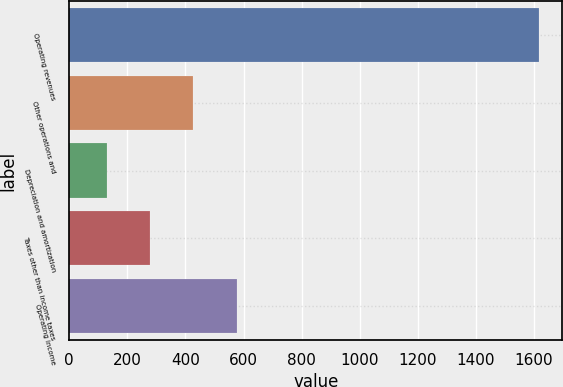Convert chart. <chart><loc_0><loc_0><loc_500><loc_500><bar_chart><fcel>Operating revenues<fcel>Other operations and<fcel>Depreciation and amortization<fcel>Taxes other than income taxes<fcel>Operating income<nl><fcel>1616<fcel>427.2<fcel>130<fcel>278.6<fcel>575.8<nl></chart> 